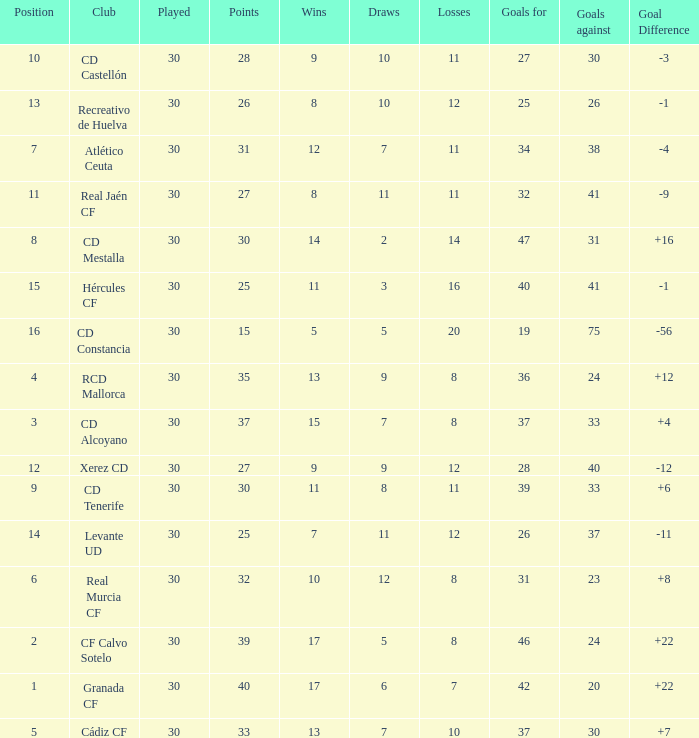How many Wins have Goals against smaller than 30, and Goals for larger than 25, and Draws larger than 5? 3.0. 